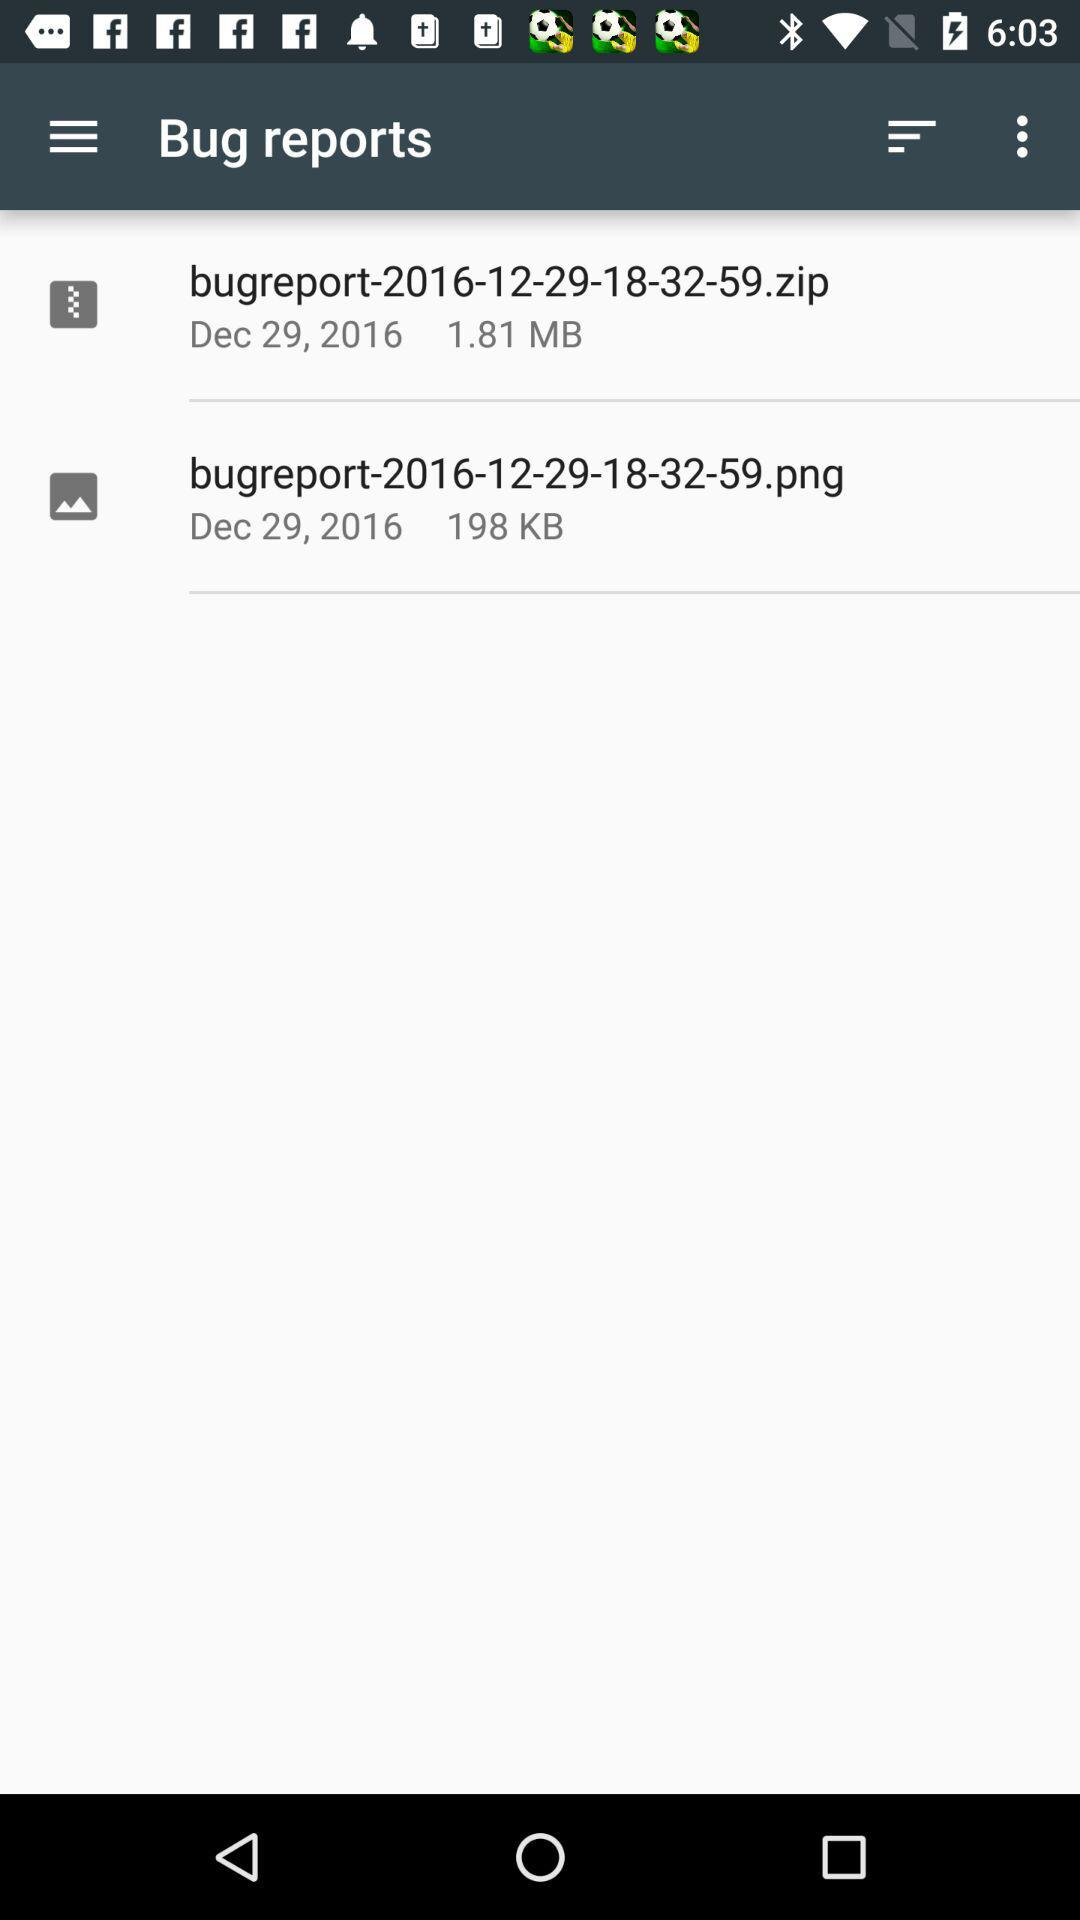What is the size of the bug reports? The sizes of the bug reports are 1.81 MB and 198 KB. 